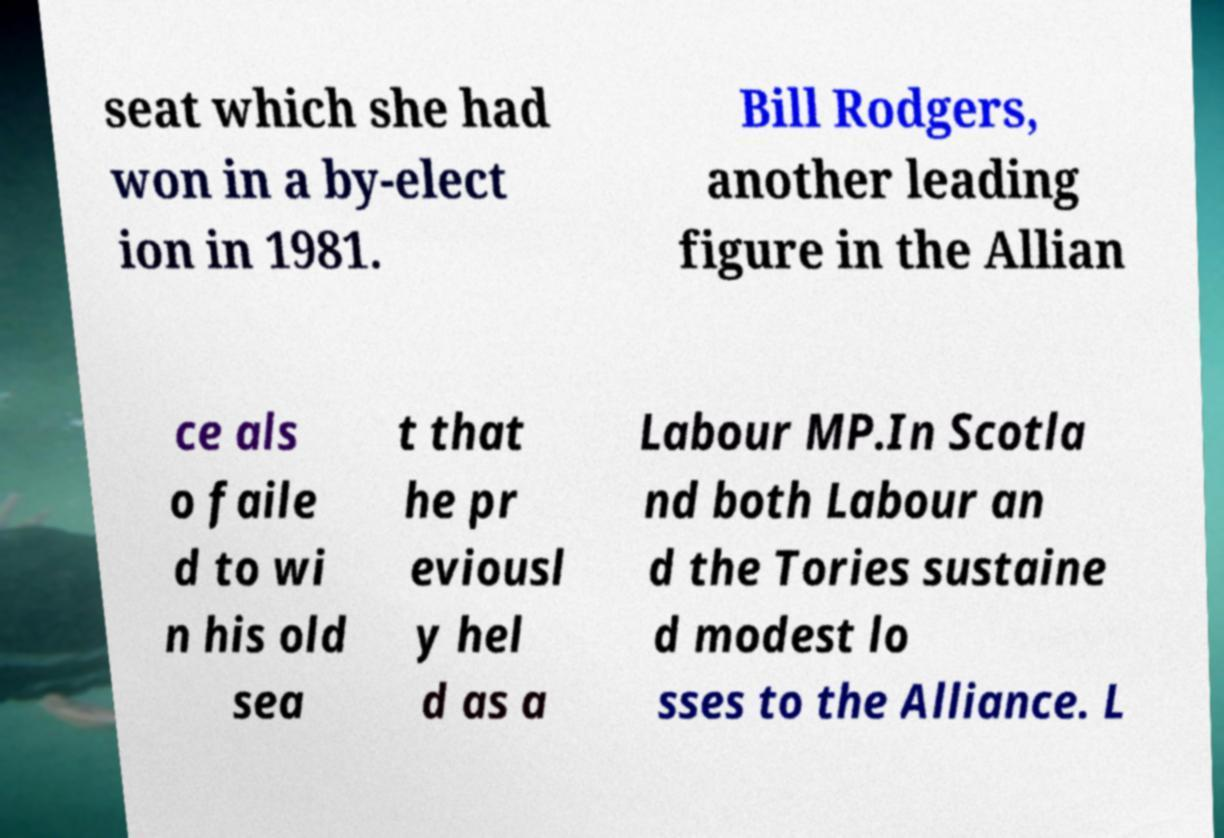Can you read and provide the text displayed in the image?This photo seems to have some interesting text. Can you extract and type it out for me? seat which she had won in a by-elect ion in 1981. Bill Rodgers, another leading figure in the Allian ce als o faile d to wi n his old sea t that he pr eviousl y hel d as a Labour MP.In Scotla nd both Labour an d the Tories sustaine d modest lo sses to the Alliance. L 